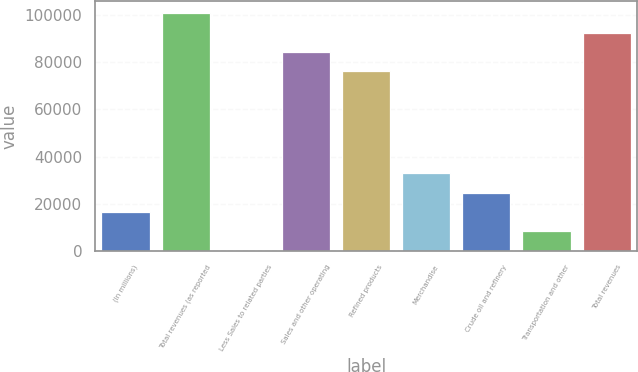Convert chart. <chart><loc_0><loc_0><loc_500><loc_500><bar_chart><fcel>(In millions)<fcel>Total revenues (as reported<fcel>Less Sales to related parties<fcel>Sales and other operating<fcel>Refined products<fcel>Merchandise<fcel>Crude oil and refinery<fcel>Transportation and other<fcel>Total revenues<nl><fcel>16455.4<fcel>100905<fcel>8<fcel>84457.7<fcel>76234<fcel>32902.8<fcel>24679.1<fcel>8231.7<fcel>92681.4<nl></chart> 